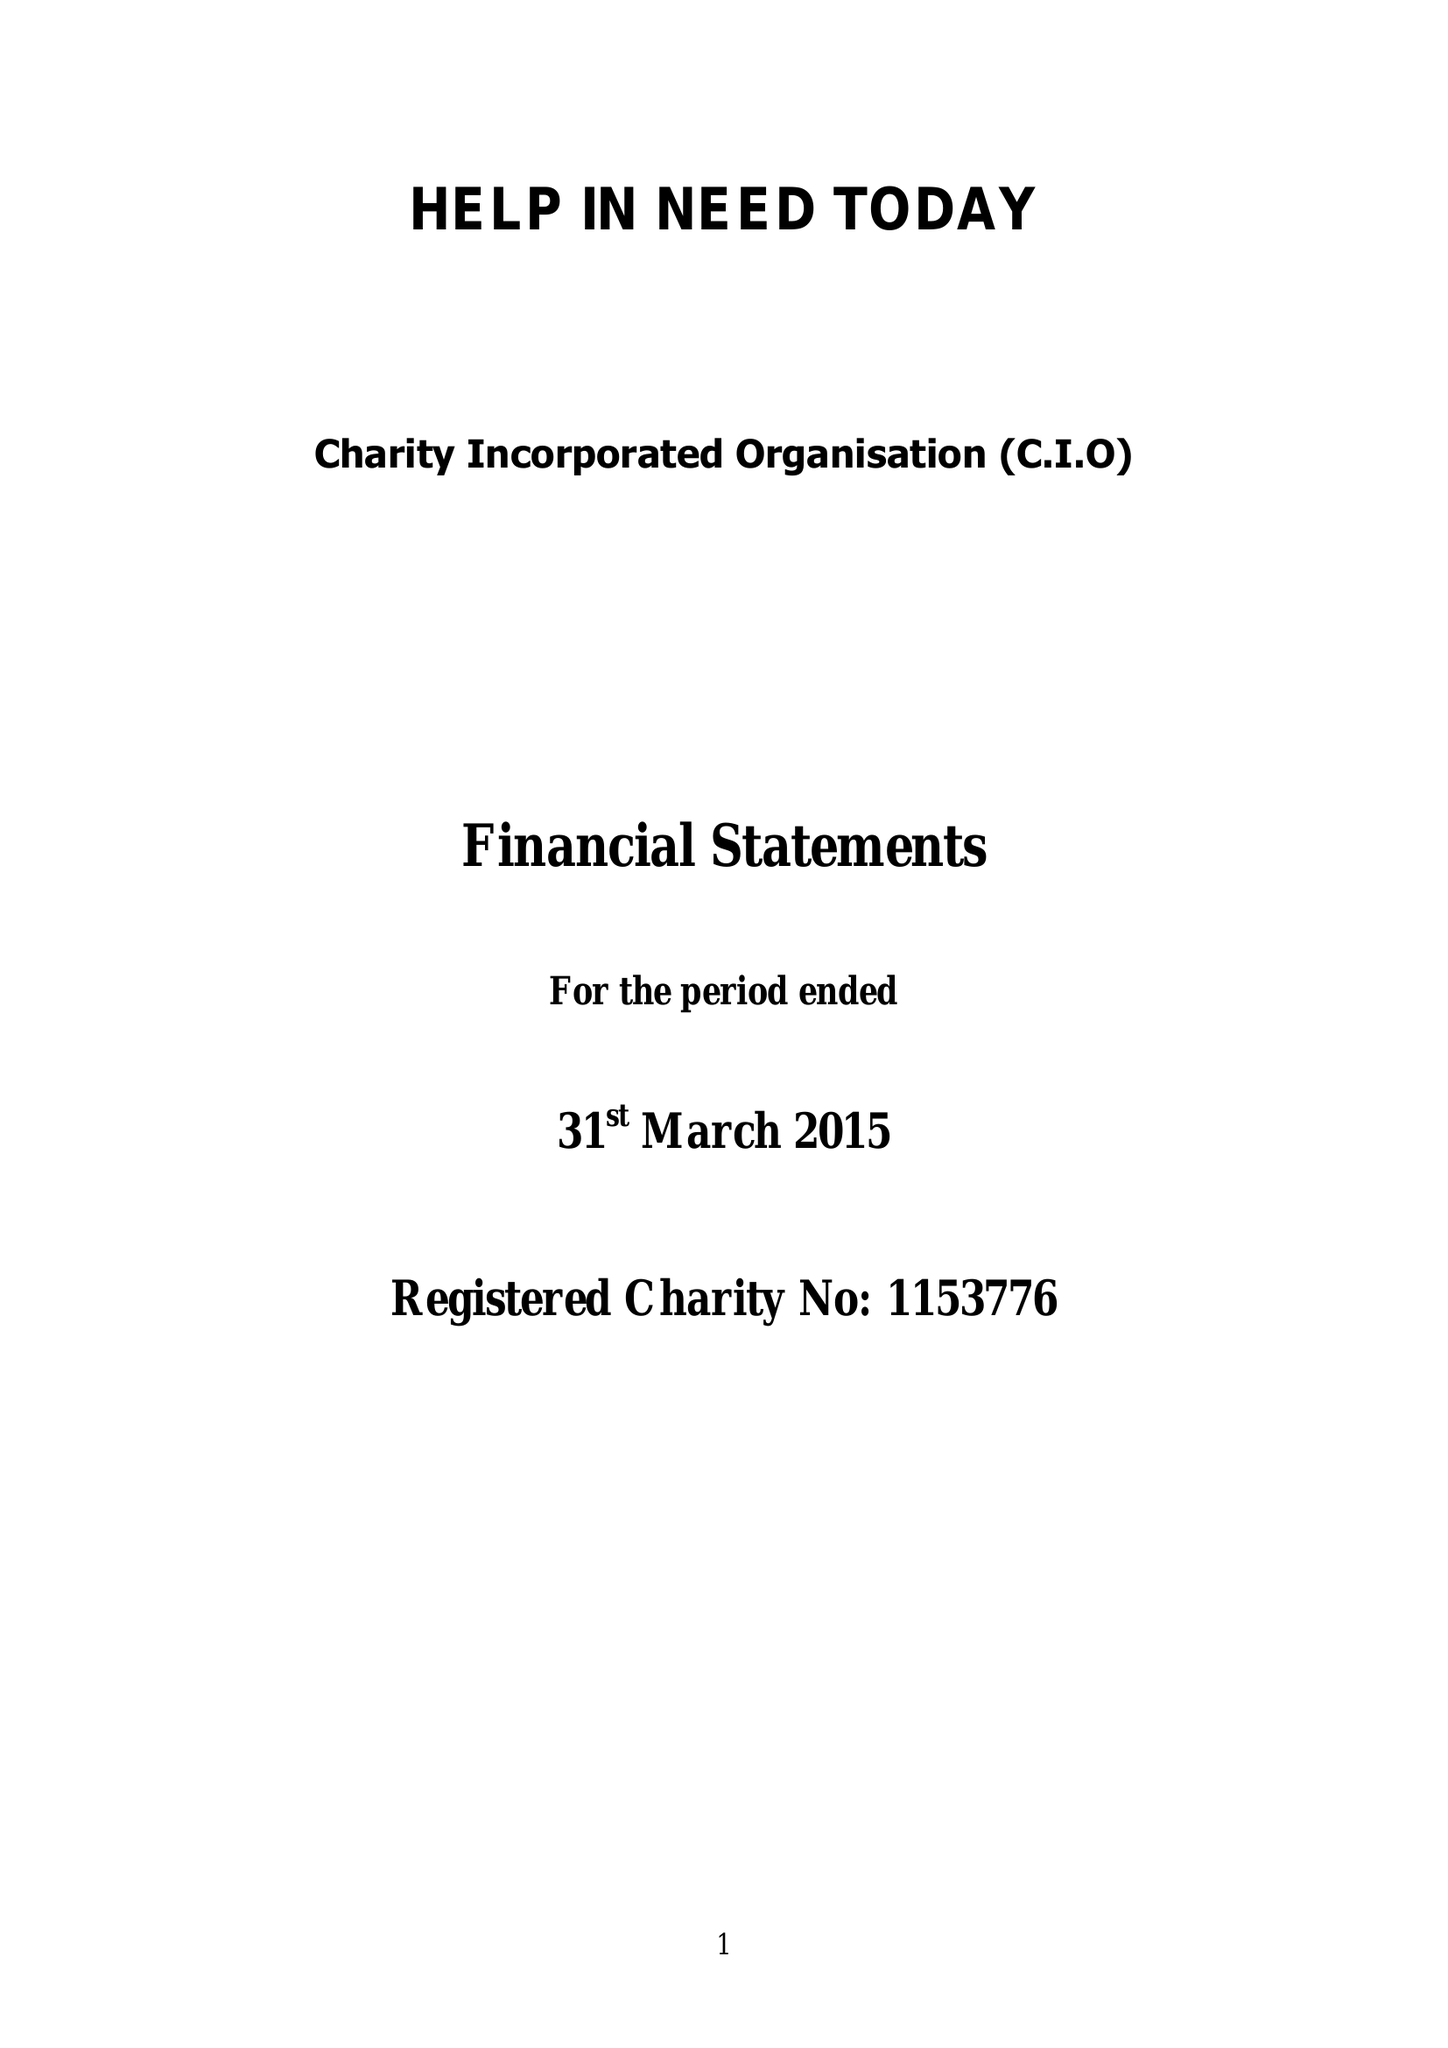What is the value for the address__postcode?
Answer the question using a single word or phrase. N13 5SR 